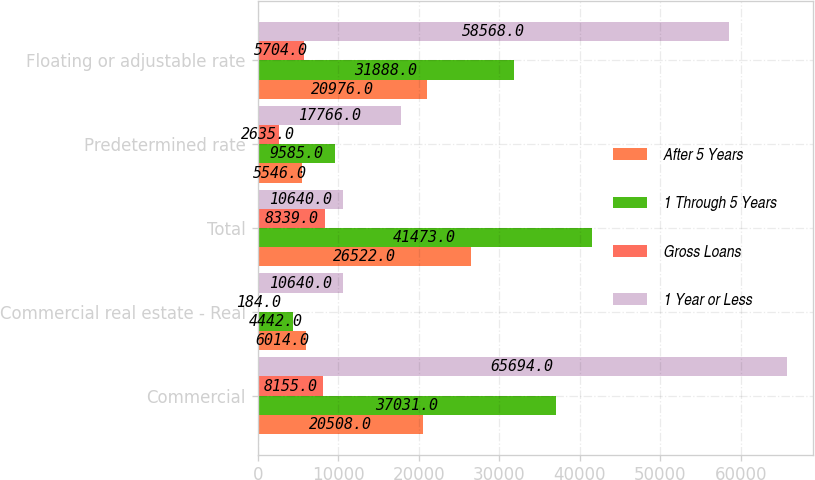Convert chart to OTSL. <chart><loc_0><loc_0><loc_500><loc_500><stacked_bar_chart><ecel><fcel>Commercial<fcel>Commercial real estate - Real<fcel>Total<fcel>Predetermined rate<fcel>Floating or adjustable rate<nl><fcel>After 5 Years<fcel>20508<fcel>6014<fcel>26522<fcel>5546<fcel>20976<nl><fcel>1 Through 5 Years<fcel>37031<fcel>4442<fcel>41473<fcel>9585<fcel>31888<nl><fcel>Gross Loans<fcel>8155<fcel>184<fcel>8339<fcel>2635<fcel>5704<nl><fcel>1 Year or Less<fcel>65694<fcel>10640<fcel>10640<fcel>17766<fcel>58568<nl></chart> 